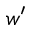<formula> <loc_0><loc_0><loc_500><loc_500>w ^ { \prime }</formula> 